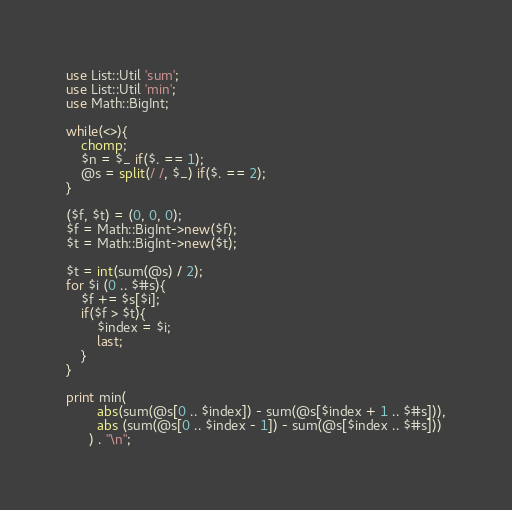Convert code to text. <code><loc_0><loc_0><loc_500><loc_500><_Perl_>use List::Util 'sum';
use List::Util 'min';
use Math::BigInt;

while(<>){
	chomp;
	$n = $_ if($. == 1);
	@s = split(/ /, $_) if($. == 2);
}

($f, $t) = (0, 0, 0);
$f = Math::BigInt->new($f);
$t = Math::BigInt->new($t);

$t = int(sum(@s) / 2);
for $i (0 .. $#s){
	$f += $s[$i];
	if($f > $t){
		$index = $i;
		last;
	}
}

print min(
		abs(sum(@s[0 .. $index]) - sum(@s[$index + 1 .. $#s])),
		abs (sum(@s[0 .. $index - 1]) - sum(@s[$index .. $#s]))
	  ) . "\n";
</code> 